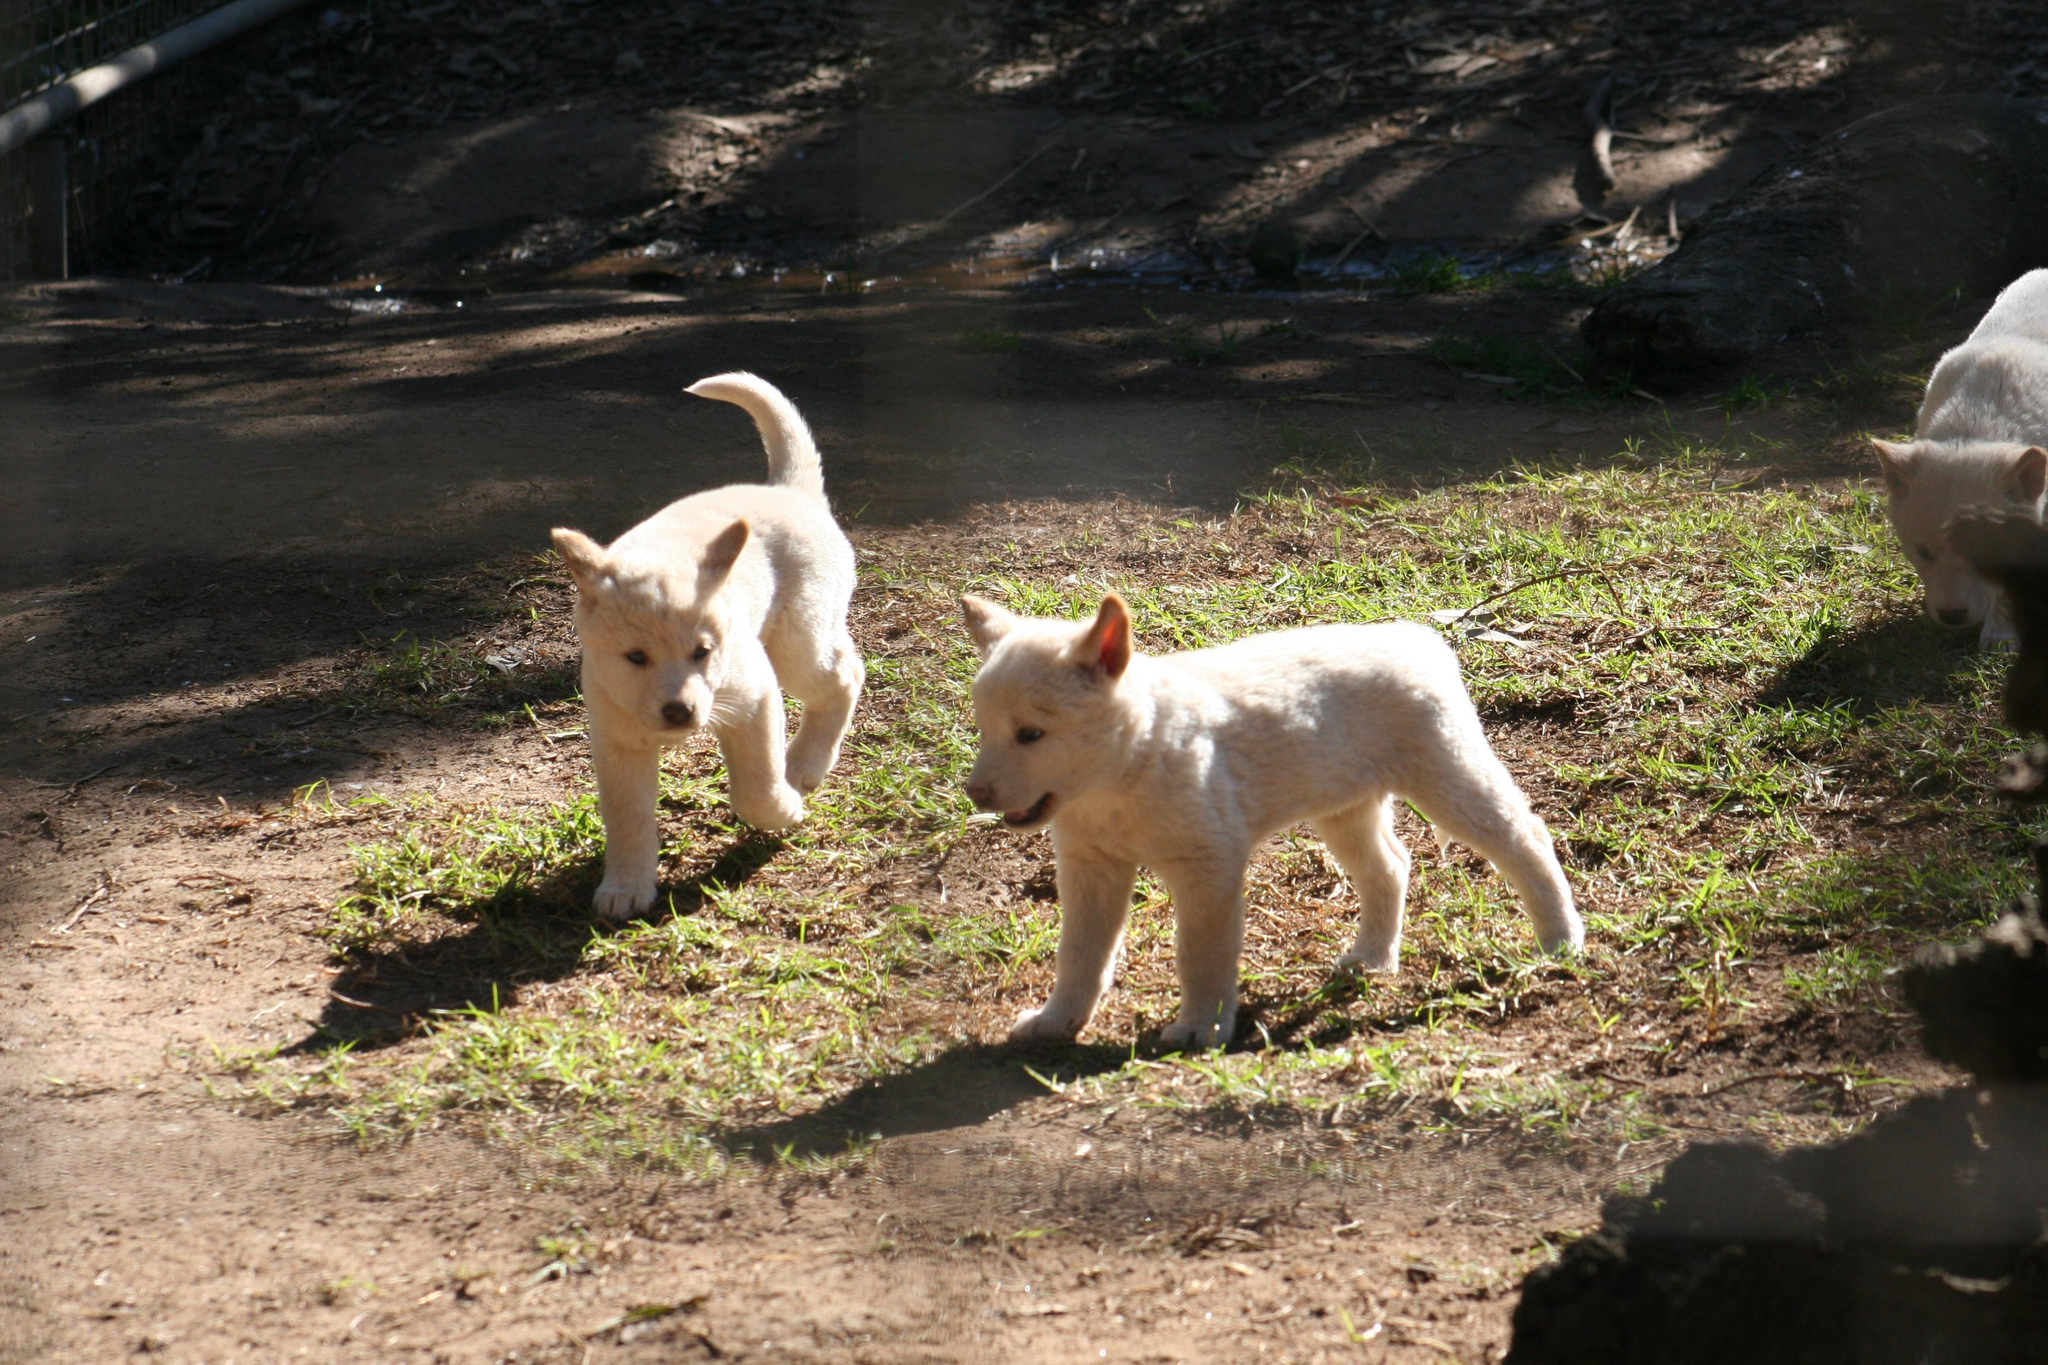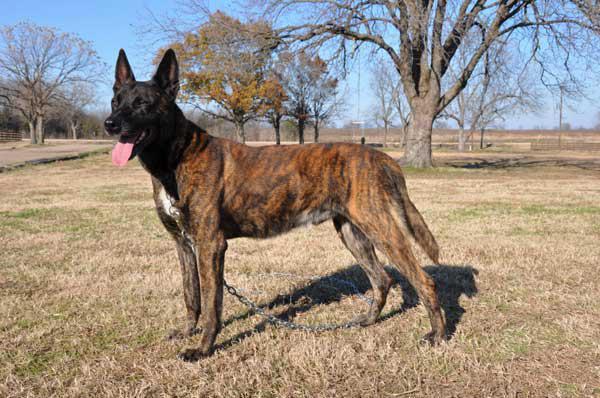The first image is the image on the left, the second image is the image on the right. For the images displayed, is the sentence "There is at least two canines in the right image." factually correct? Answer yes or no. No. The first image is the image on the left, the second image is the image on the right. For the images shown, is this caption "In at least one image there is a single male in camo clothes holding a hunting gun near the dead brown fox." true? Answer yes or no. No. 